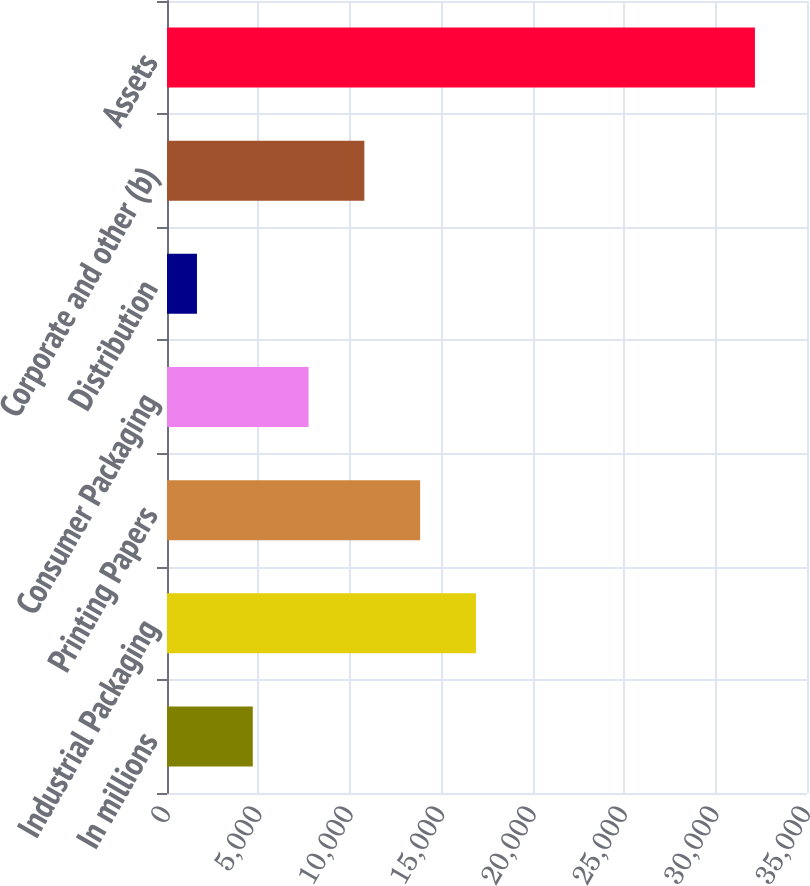Convert chart. <chart><loc_0><loc_0><loc_500><loc_500><bar_chart><fcel>In millions<fcel>Industrial Packaging<fcel>Printing Papers<fcel>Consumer Packaging<fcel>Distribution<fcel>Corporate and other (b)<fcel>Assets<nl><fcel>4690.4<fcel>16896<fcel>13844.6<fcel>7741.8<fcel>1639<fcel>10793.2<fcel>32153<nl></chart> 